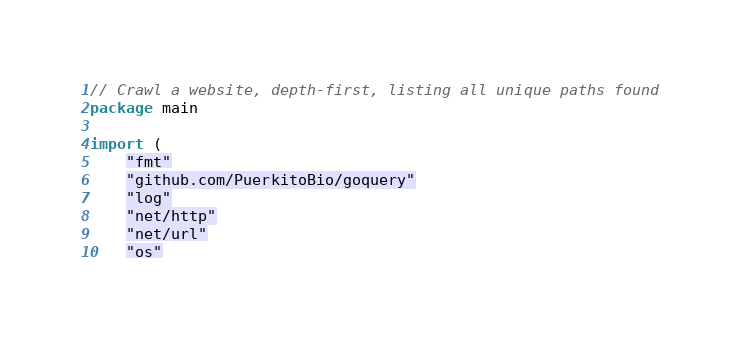<code> <loc_0><loc_0><loc_500><loc_500><_Go_>// Crawl a website, depth-first, listing all unique paths found
package main

import (
	"fmt"
	"github.com/PuerkitoBio/goquery"
	"log"
	"net/http"
	"net/url"
	"os"</code> 